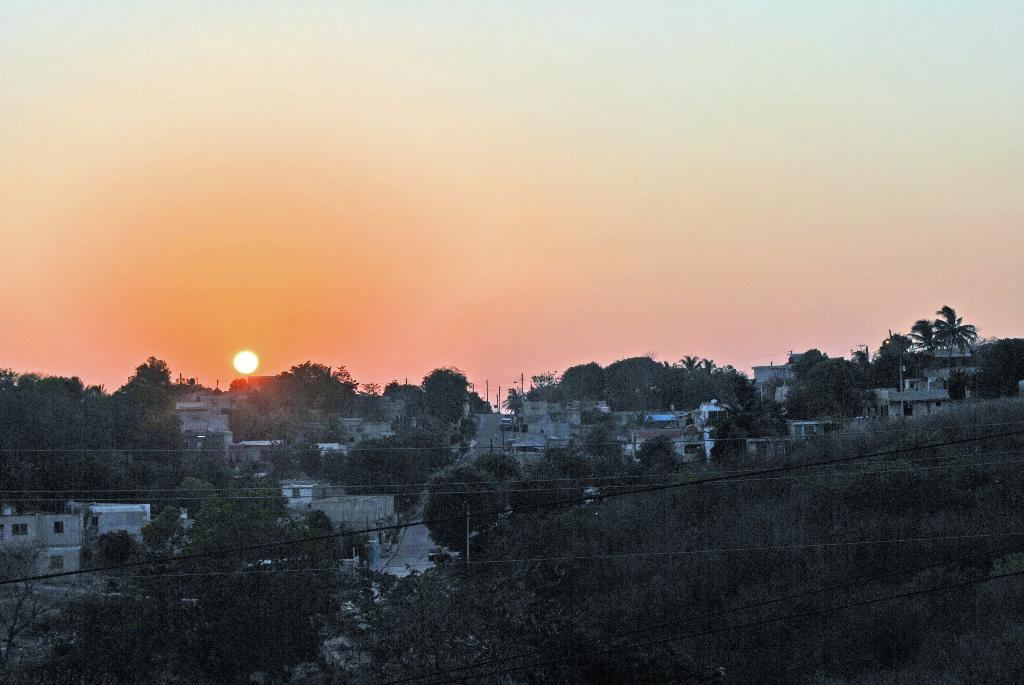What type of structures can be seen in the image? There are houses in the image. What type of natural elements are present in the image? There are trees in the image. What man-made objects can be seen in the image? There are wires in the image. What celestial body is visible in the image? The sun is visible in the image. What part of the natural environment is visible in the image? The sky is visible in the image. What type of size is the quartz in the image? There is no quartz present in the image. How many parcels are visible in the image? There are no parcels present in the image. 